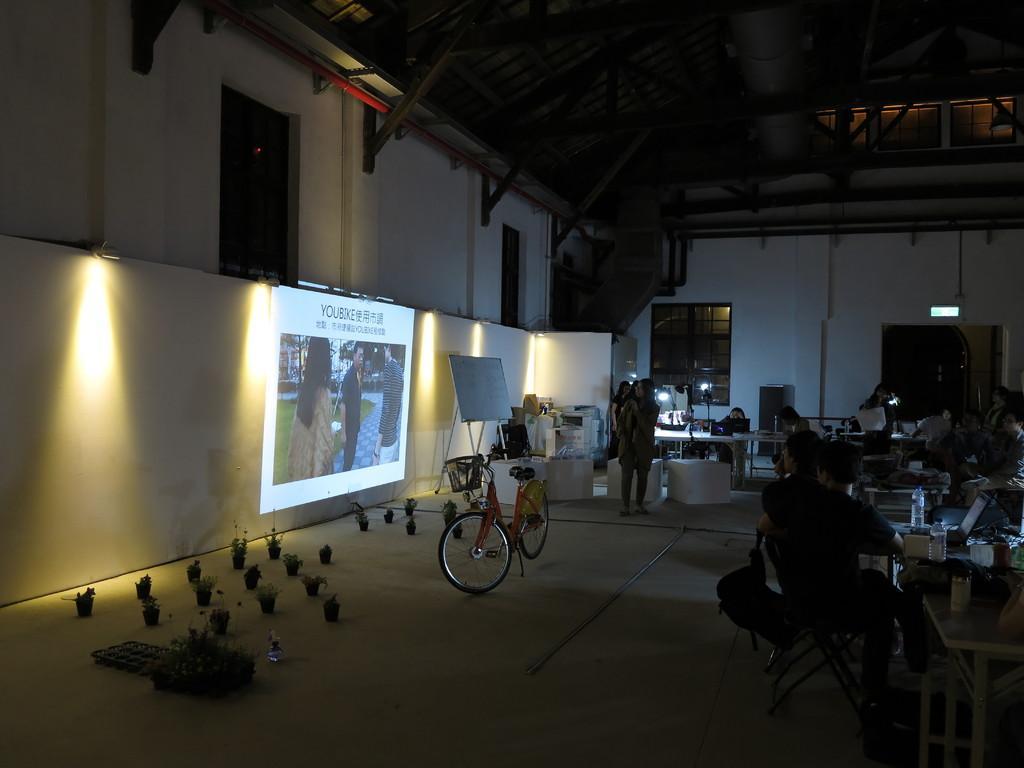Can you describe this image briefly? In the image I can see people among them some are standing and some are sitting on chairs in front of tables. On tables I can see a bottle and some other objects. On the left side of the image I can see a bicycle, a projector screen, lights on the wall, white color board, windows and some other objects on the ground. 